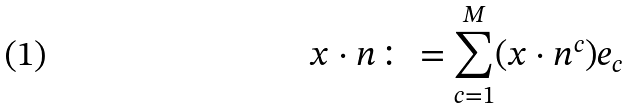Convert formula to latex. <formula><loc_0><loc_0><loc_500><loc_500>x \cdot { n } \colon = \sum _ { c = 1 } ^ { M } ( x \cdot n ^ { c } ) { e } _ { c }</formula> 